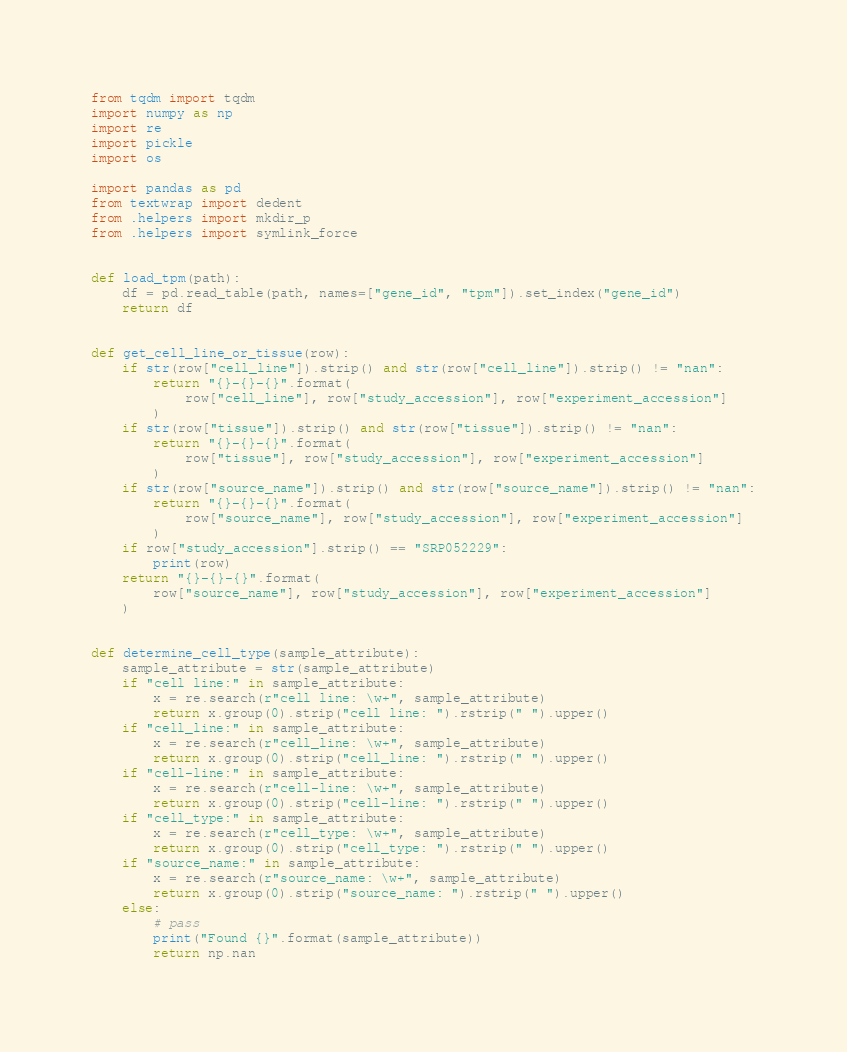Convert code to text. <code><loc_0><loc_0><loc_500><loc_500><_Python_>from tqdm import tqdm
import numpy as np
import re
import pickle
import os

import pandas as pd
from textwrap import dedent
from .helpers import mkdir_p
from .helpers import symlink_force


def load_tpm(path):
    df = pd.read_table(path, names=["gene_id", "tpm"]).set_index("gene_id")
    return df


def get_cell_line_or_tissue(row):
    if str(row["cell_line"]).strip() and str(row["cell_line"]).strip() != "nan":
        return "{}-{}-{}".format(
            row["cell_line"], row["study_accession"], row["experiment_accession"]
        )
    if str(row["tissue"]).strip() and str(row["tissue"]).strip() != "nan":
        return "{}-{}-{}".format(
            row["tissue"], row["study_accession"], row["experiment_accession"]
        )
    if str(row["source_name"]).strip() and str(row["source_name"]).strip() != "nan":
        return "{}-{}-{}".format(
            row["source_name"], row["study_accession"], row["experiment_accession"]
        )
    if row["study_accession"].strip() == "SRP052229":
        print(row)
    return "{}-{}-{}".format(
        row["source_name"], row["study_accession"], row["experiment_accession"]
    )


def determine_cell_type(sample_attribute):
    sample_attribute = str(sample_attribute)
    if "cell line:" in sample_attribute:
        x = re.search(r"cell line: \w+", sample_attribute)
        return x.group(0).strip("cell line: ").rstrip(" ").upper()
    if "cell_line:" in sample_attribute:
        x = re.search(r"cell_line: \w+", sample_attribute)
        return x.group(0).strip("cell_line: ").rstrip(" ").upper()
    if "cell-line:" in sample_attribute:
        x = re.search(r"cell-line: \w+", sample_attribute)
        return x.group(0).strip("cell-line: ").rstrip(" ").upper()
    if "cell_type:" in sample_attribute:
        x = re.search(r"cell_type: \w+", sample_attribute)
        return x.group(0).strip("cell_type: ").rstrip(" ").upper()
    if "source_name:" in sample_attribute:
        x = re.search(r"source_name: \w+", sample_attribute)
        return x.group(0).strip("source_name: ").rstrip(" ").upper()
    else:
        # pass
        print("Found {}".format(sample_attribute))
        return np.nan

</code> 